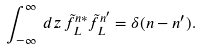Convert formula to latex. <formula><loc_0><loc_0><loc_500><loc_500>\int _ { - \infty } ^ { \infty } \, d z \, \tilde { f } _ { L } ^ { n * } \tilde { f } _ { L } ^ { n ^ { \prime } } = \delta ( n - n ^ { \prime } ) .</formula> 